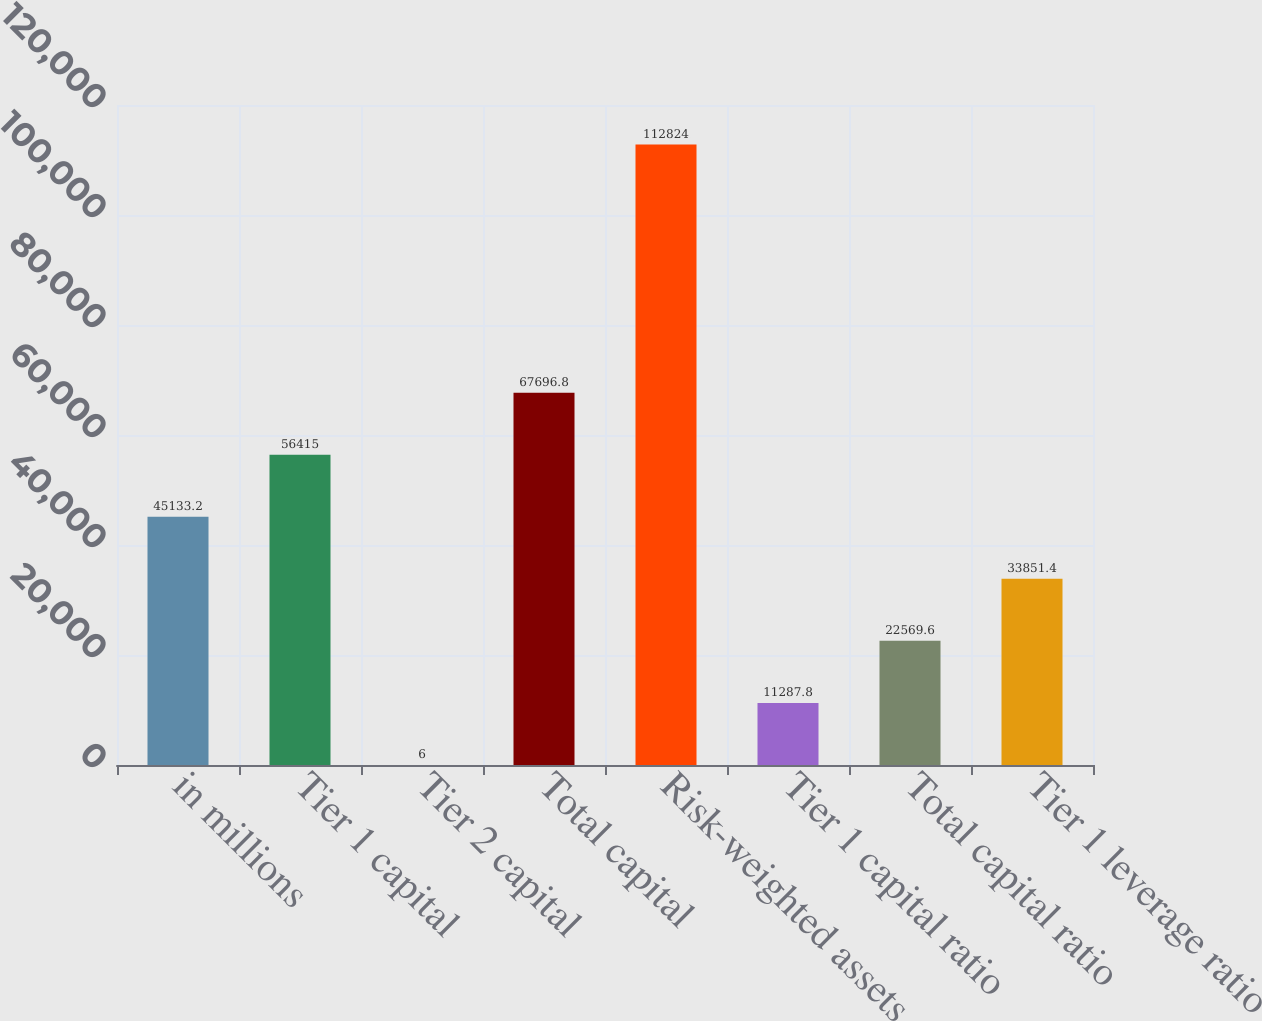Convert chart to OTSL. <chart><loc_0><loc_0><loc_500><loc_500><bar_chart><fcel>in millions<fcel>Tier 1 capital<fcel>Tier 2 capital<fcel>Total capital<fcel>Risk-weighted assets<fcel>Tier 1 capital ratio<fcel>Total capital ratio<fcel>Tier 1 leverage ratio<nl><fcel>45133.2<fcel>56415<fcel>6<fcel>67696.8<fcel>112824<fcel>11287.8<fcel>22569.6<fcel>33851.4<nl></chart> 